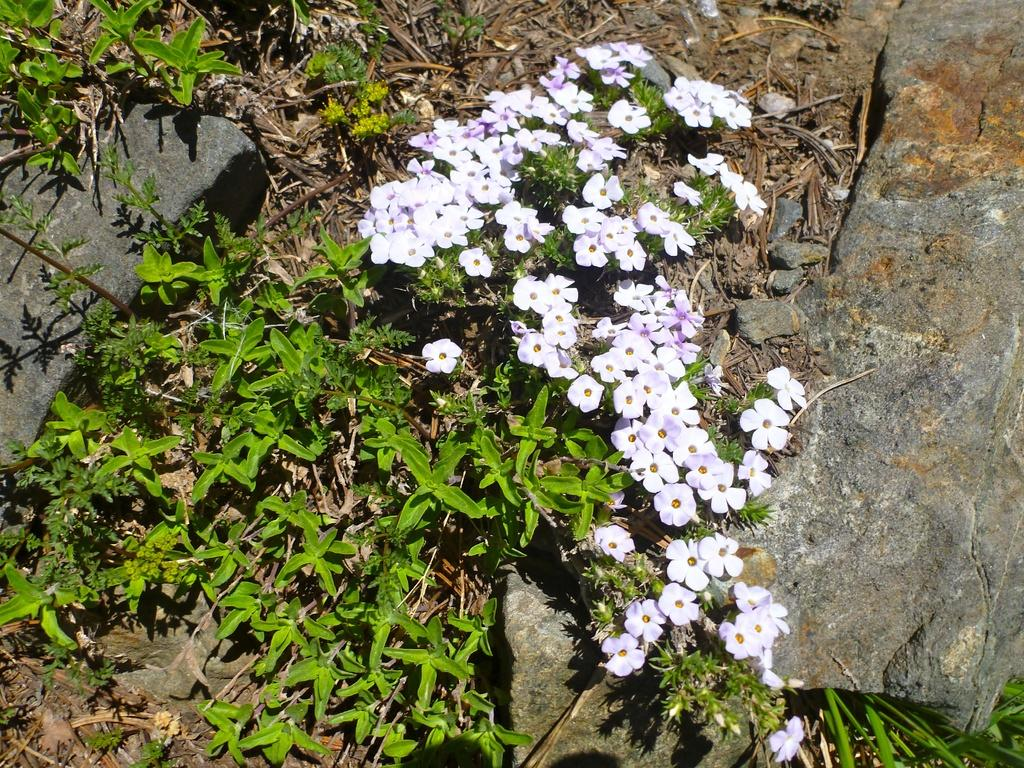What type of living organisms can be seen in the image? There are flowers and plants visible in the image. What type of inanimate objects can be seen in the image? There are stones visible in the image. What type of roof can be seen in the image? There is no roof present in the image; it features flowers, plants, and stones. 